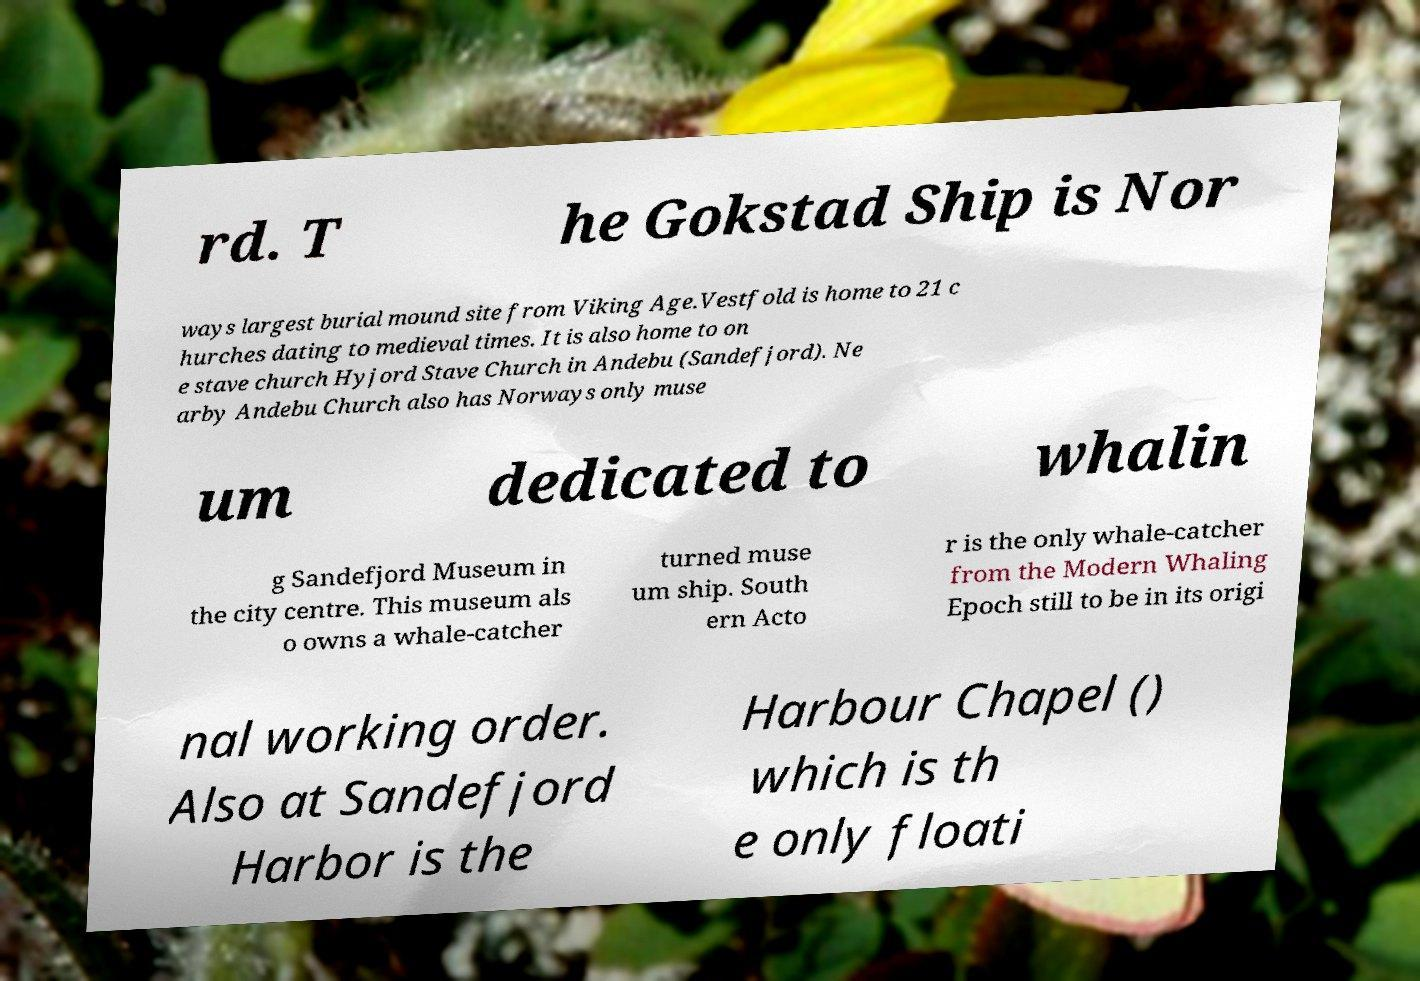What messages or text are displayed in this image? I need them in a readable, typed format. rd. T he Gokstad Ship is Nor ways largest burial mound site from Viking Age.Vestfold is home to 21 c hurches dating to medieval times. It is also home to on e stave church Hyjord Stave Church in Andebu (Sandefjord). Ne arby Andebu Church also has Norways only muse um dedicated to whalin g Sandefjord Museum in the city centre. This museum als o owns a whale-catcher turned muse um ship. South ern Acto r is the only whale-catcher from the Modern Whaling Epoch still to be in its origi nal working order. Also at Sandefjord Harbor is the Harbour Chapel () which is th e only floati 